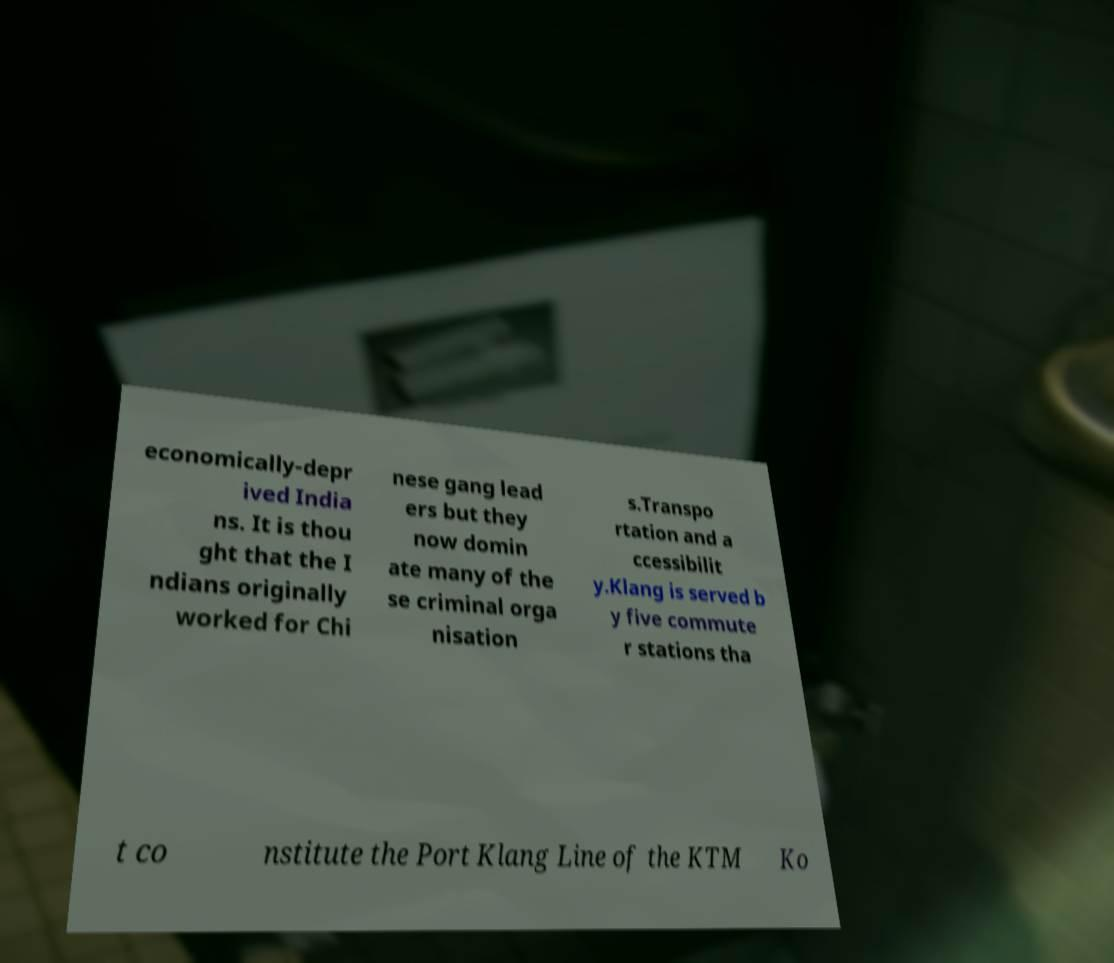Please read and relay the text visible in this image. What does it say? economically-depr ived India ns. It is thou ght that the I ndians originally worked for Chi nese gang lead ers but they now domin ate many of the se criminal orga nisation s.Transpo rtation and a ccessibilit y.Klang is served b y five commute r stations tha t co nstitute the Port Klang Line of the KTM Ko 